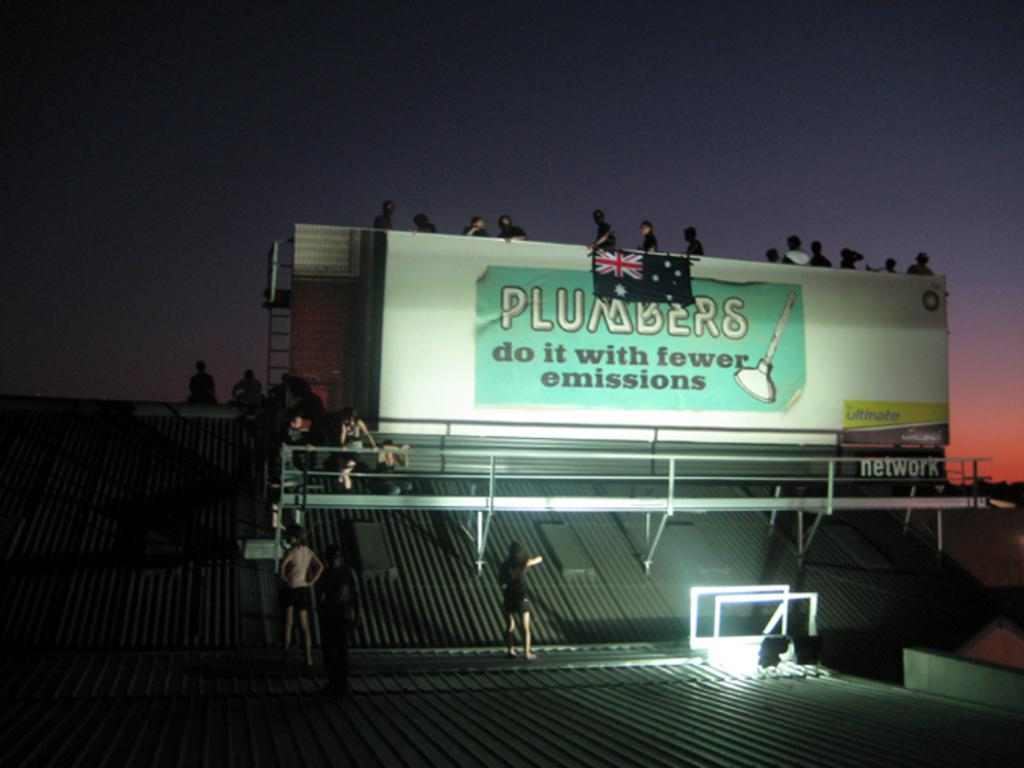<image>
Share a concise interpretation of the image provided. A large lit billboard with the ad that reads plumbers do it with fewer emissions. 